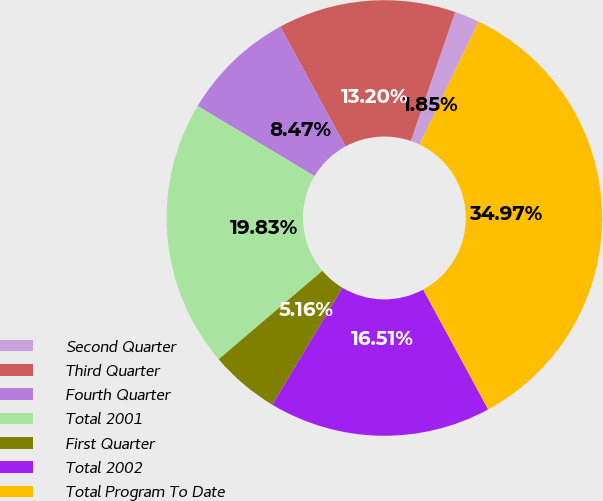Convert chart. <chart><loc_0><loc_0><loc_500><loc_500><pie_chart><fcel>Second Quarter<fcel>Third Quarter<fcel>Fourth Quarter<fcel>Total 2001<fcel>First Quarter<fcel>Total 2002<fcel>Total Program To Date<nl><fcel>1.85%<fcel>13.2%<fcel>8.47%<fcel>19.83%<fcel>5.16%<fcel>16.51%<fcel>34.97%<nl></chart> 